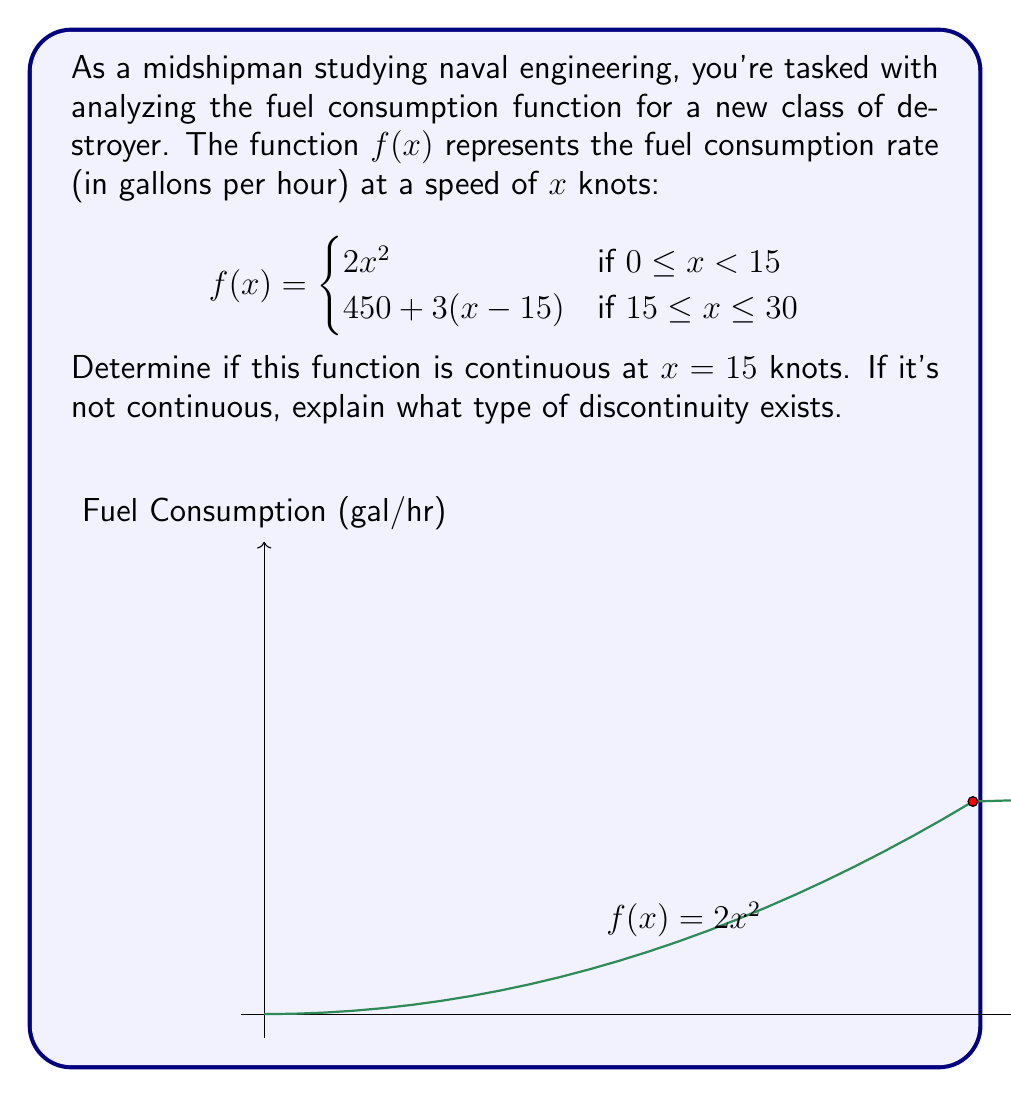Could you help me with this problem? To determine if the function is continuous at $x = 15$, we need to check three conditions:

1. $f(15)$ exists
2. $\lim_{x \to 15^-} f(x)$ exists
3. $\lim_{x \to 15^+} f(x)$ exists
4. All three values are equal

Step 1: Calculate $f(15)$
Using the second piece of the function:
$f(15) = 450 + 3(15-15) = 450$

Step 2: Calculate $\lim_{x \to 15^-} f(x)$
Using the first piece of the function:
$\lim_{x \to 15^-} f(x) = \lim_{x \to 15^-} 2x^2 = 2(15)^2 = 450$

Step 3: Calculate $\lim_{x \to 15^+} f(x)$
Using the second piece of the function:
$\lim_{x \to 15^+} f(x) = \lim_{x \to 15^+} [450 + 3(x-15)] = 450 + 3(15-15) = 450$

Step 4: Compare the values
$f(15) = 450$
$\lim_{x \to 15^-} f(x) = 450$
$\lim_{x \to 15^+} f(x) = 450$

All three values are equal to 450, satisfying all conditions for continuity.
Answer: The function is continuous at $x = 15$ knots. 